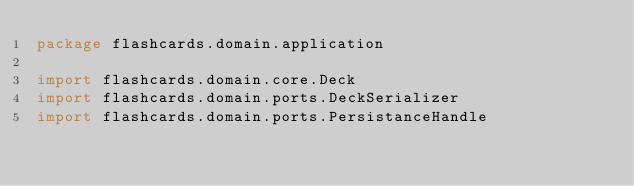Convert code to text. <code><loc_0><loc_0><loc_500><loc_500><_Kotlin_>package flashcards.domain.application

import flashcards.domain.core.Deck
import flashcards.domain.ports.DeckSerializer
import flashcards.domain.ports.PersistanceHandle
</code> 